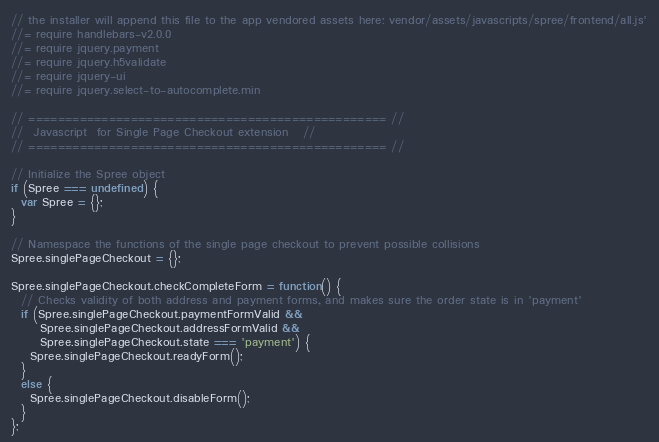Convert code to text. <code><loc_0><loc_0><loc_500><loc_500><_JavaScript_>// the installer will append this file to the app vendored assets here: vendor/assets/javascripts/spree/frontend/all.js'
//= require handlebars-v2.0.0
//= require jquery.payment
//= require jquery.h5validate
//= require jquery-ui
//= require jquery.select-to-autocomplete.min

// ================================================= //
//  Javascript  for Single Page Checkout extension   //
// ================================================= //

// Initialize the Spree object
if (Spree === undefined) {
  var Spree = {};
}

// Namespace the functions of the single page checkout to prevent possible collisions
Spree.singlePageCheckout = {};

Spree.singlePageCheckout.checkCompleteForm = function() {
  // Checks validity of both address and payment forms, and makes sure the order state is in 'payment'
  if (Spree.singlePageCheckout.paymentFormValid &&
      Spree.singlePageCheckout.addressFormValid &&
      Spree.singlePageCheckout.state === 'payment') {
    Spree.singlePageCheckout.readyForm();
  }
  else {
    Spree.singlePageCheckout.disableForm();
  }
};
</code> 